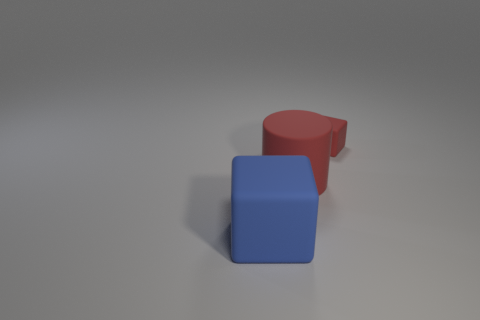Is the size of the red block the same as the red matte cylinder?
Your response must be concise. No. What is the material of the big red thing?
Offer a very short reply. Rubber. What color is the big cylinder that is made of the same material as the small red cube?
Your response must be concise. Red. Does the small object have the same material as the block that is left of the tiny red cube?
Your response must be concise. Yes. What number of yellow objects are the same material as the big block?
Ensure brevity in your answer.  0. There is a big rubber thing that is behind the large blue rubber cube; what shape is it?
Your answer should be compact. Cylinder. Is the material of the red thing on the left side of the tiny red cube the same as the block that is in front of the large matte cylinder?
Your response must be concise. Yes. Is there a big blue rubber object of the same shape as the tiny red matte thing?
Your response must be concise. Yes. What number of objects are rubber things behind the blue object or big rubber cylinders?
Provide a succinct answer. 2. Is the number of red matte cylinders on the right side of the cylinder greater than the number of large objects that are right of the big blue matte object?
Ensure brevity in your answer.  No. 